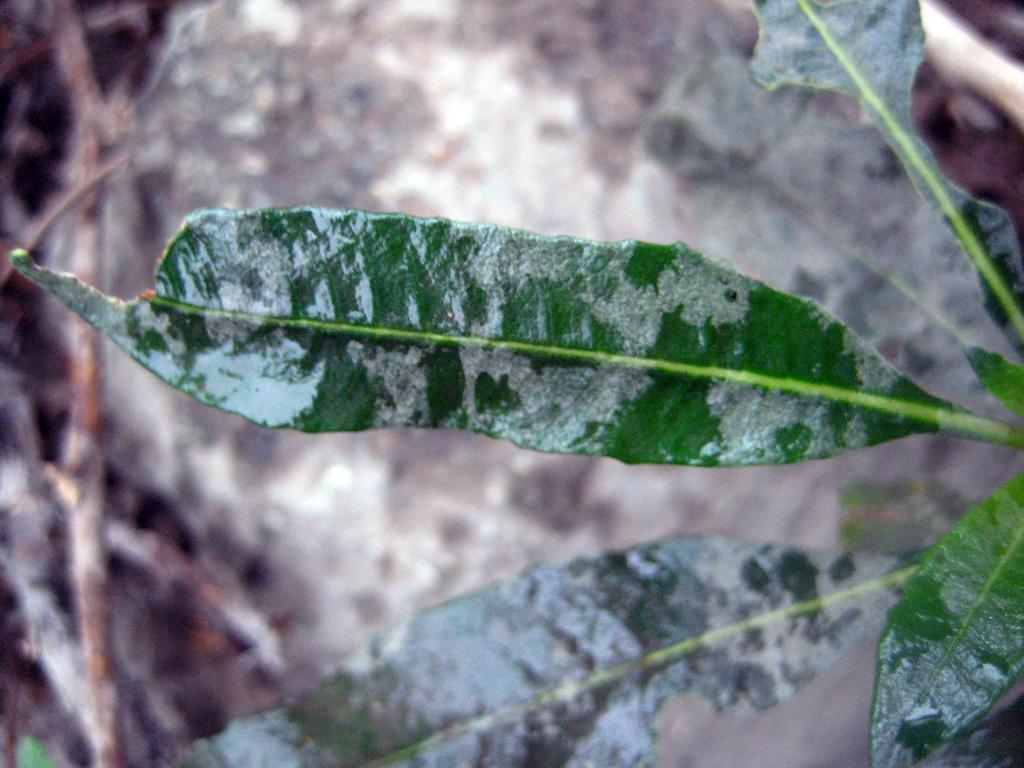What type of objects can be seen in the image? There are leaves in the image. What is the color of the leaves? The leaves are green in color. Can you describe the background of the image? The background of the image is blurred. What type of furniture is visible in the image? There is no furniture present in the image; it features leaves with a blurred background. What type of collar can be seen on the leaves in the image? There is no collar present on the leaves in the image; they are simply green leaves. 